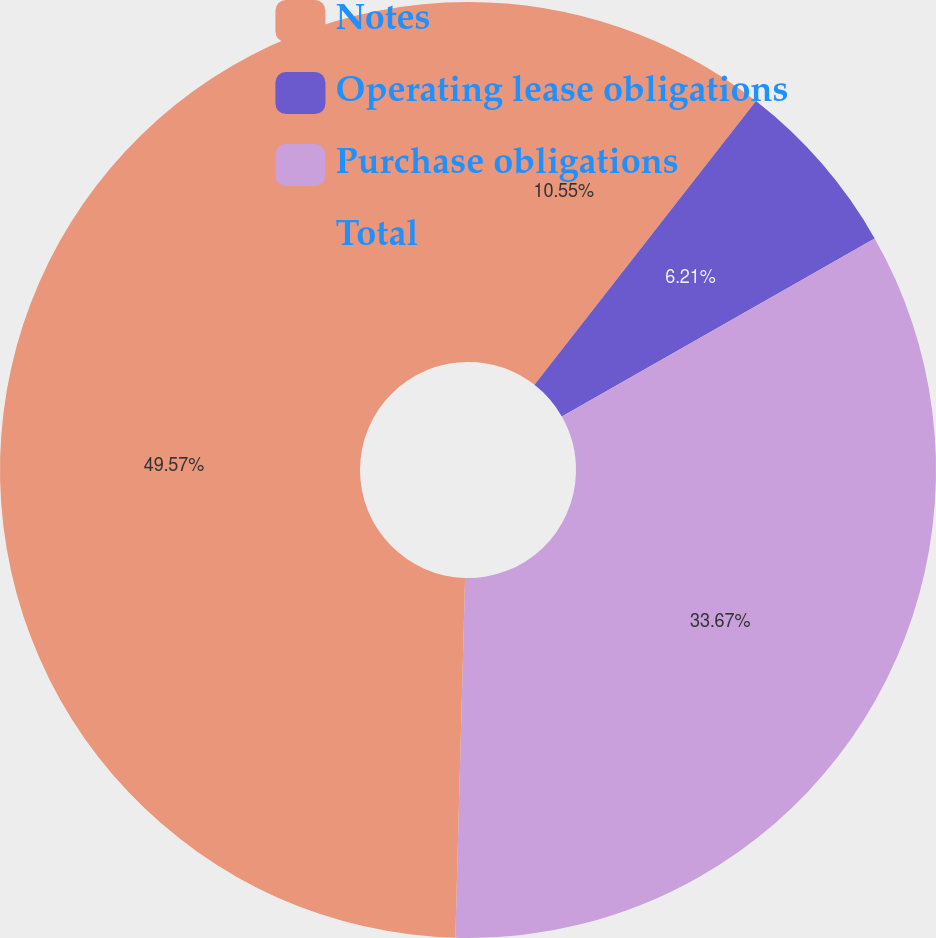Convert chart. <chart><loc_0><loc_0><loc_500><loc_500><pie_chart><fcel>Notes<fcel>Operating lease obligations<fcel>Purchase obligations<fcel>Total<nl><fcel>10.55%<fcel>6.21%<fcel>33.67%<fcel>49.57%<nl></chart> 